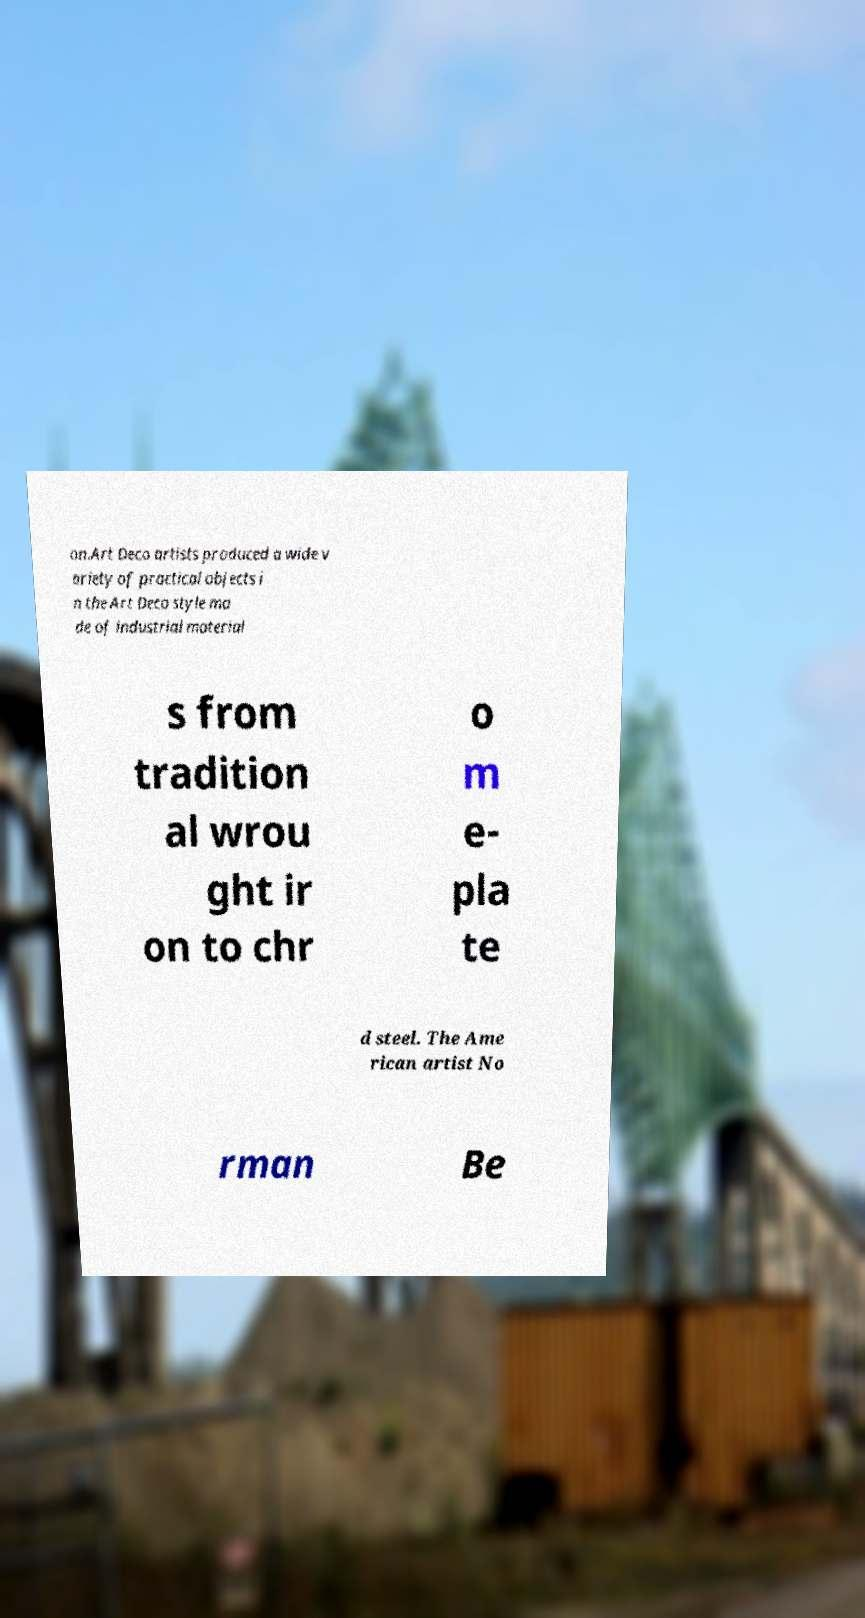Can you accurately transcribe the text from the provided image for me? on.Art Deco artists produced a wide v ariety of practical objects i n the Art Deco style ma de of industrial material s from tradition al wrou ght ir on to chr o m e- pla te d steel. The Ame rican artist No rman Be 